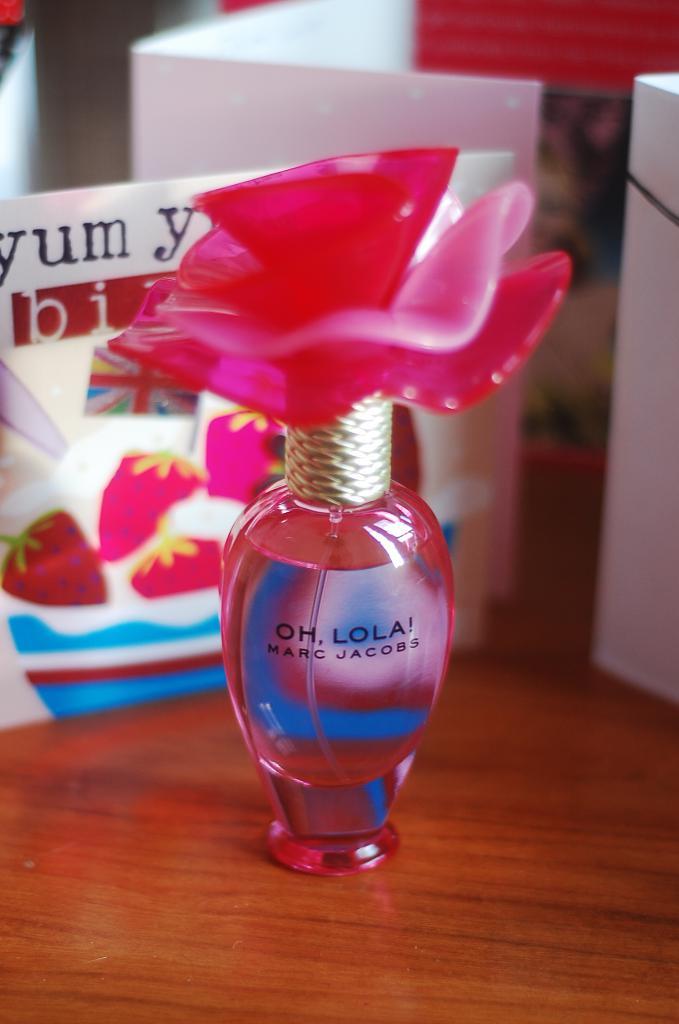What does the top part of the perfume say?
Provide a short and direct response. Oh, lola!. 